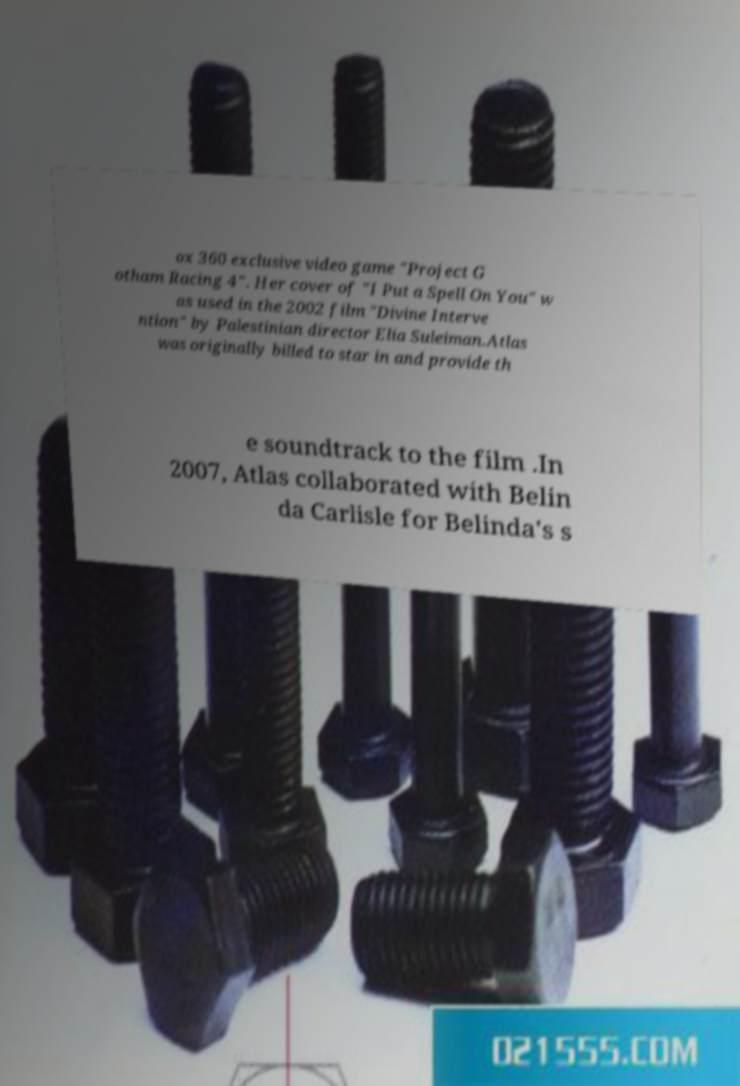There's text embedded in this image that I need extracted. Can you transcribe it verbatim? ox 360 exclusive video game "Project G otham Racing 4". Her cover of "I Put a Spell On You" w as used in the 2002 film "Divine Interve ntion" by Palestinian director Elia Suleiman.Atlas was originally billed to star in and provide th e soundtrack to the film .In 2007, Atlas collaborated with Belin da Carlisle for Belinda's s 